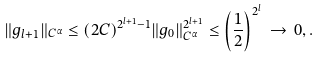<formula> <loc_0><loc_0><loc_500><loc_500>\| g _ { l + 1 } \| _ { C ^ { \alpha } } \leq ( 2 C ) ^ { 2 ^ { l + 1 } - 1 } \| g _ { 0 } \| ^ { 2 ^ { l + 1 } } _ { C ^ { \alpha } } \leq \left ( \frac { 1 } { 2 } \right ) ^ { 2 ^ { l } } \, \rightarrow \, 0 , .</formula> 